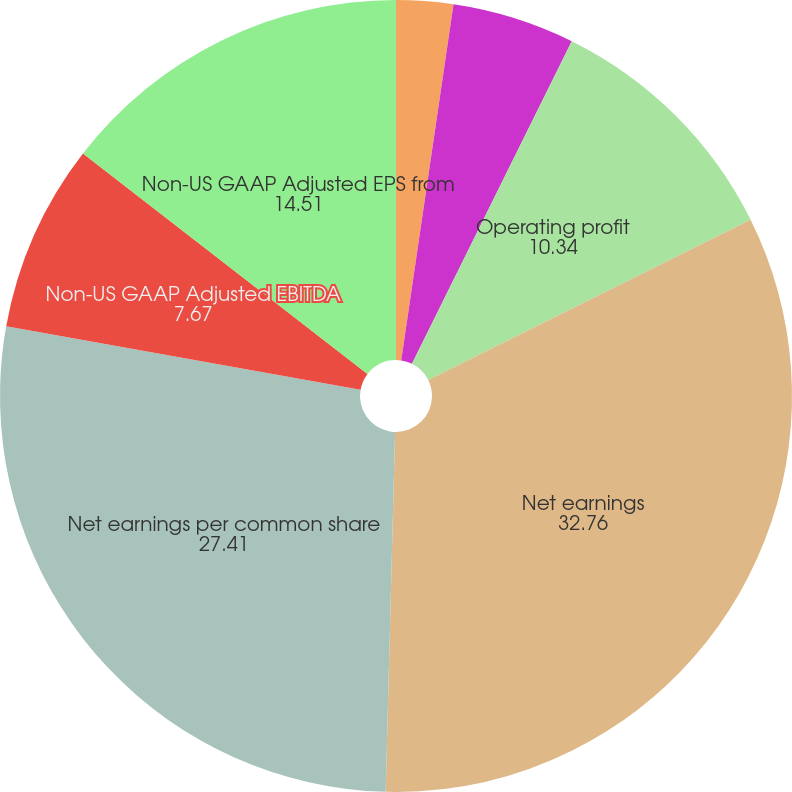Convert chart. <chart><loc_0><loc_0><loc_500><loc_500><pie_chart><fcel>Net sales<fcel>Gross profit<fcel>Operating profit<fcel>Net earnings<fcel>Net earnings per common share<fcel>Non-US GAAP Adjusted EBITDA<fcel>Non-US GAAP Adjusted EPS from<nl><fcel>2.32%<fcel>5.0%<fcel>10.34%<fcel>32.76%<fcel>27.41%<fcel>7.67%<fcel>14.51%<nl></chart> 